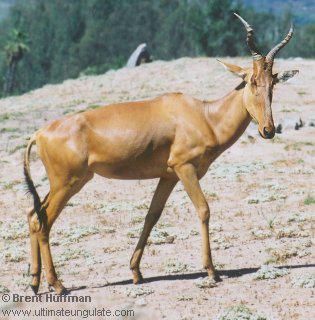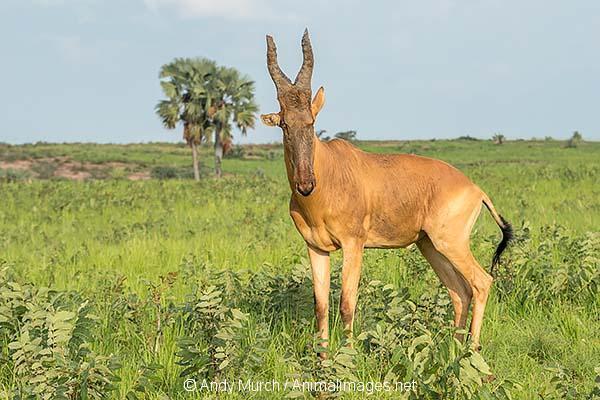The first image is the image on the left, the second image is the image on the right. Assess this claim about the two images: "The left and right image contains the same number of elk walking right.". Correct or not? Answer yes or no. No. The first image is the image on the left, the second image is the image on the right. Considering the images on both sides, is "The left image features one horned animal standing with its body aimed rightward and its head turned forward, and the right image features a horned animal standing with body and head aimed rightward." valid? Answer yes or no. No. 